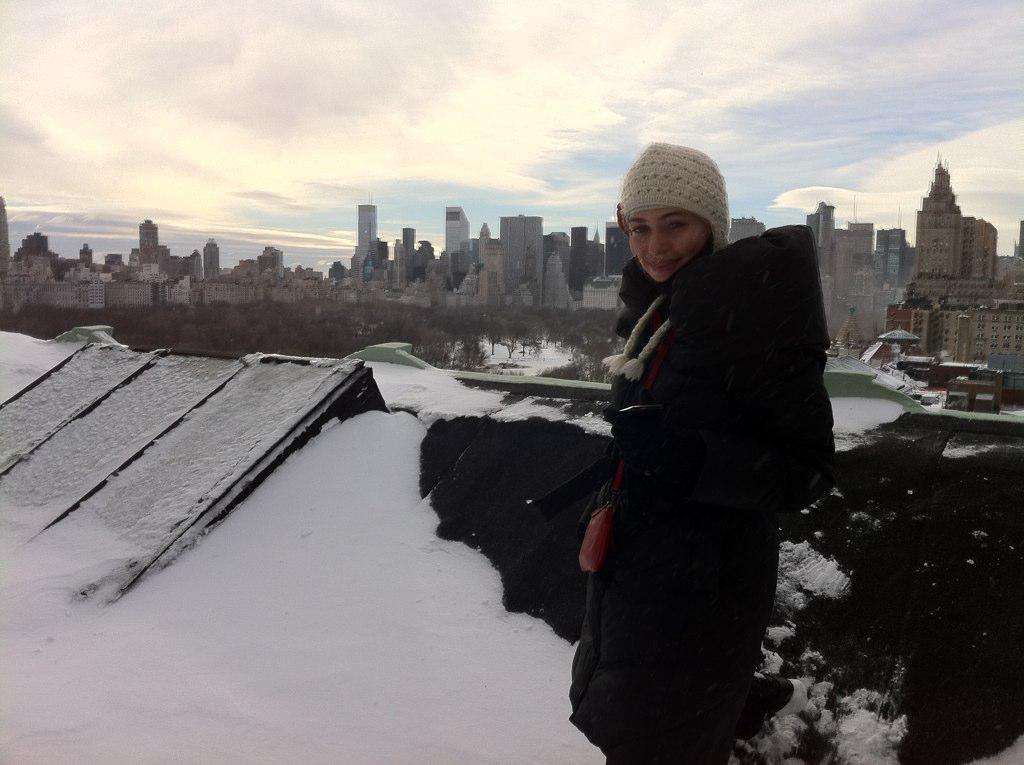What is the main subject of the image? There is a woman standing in the image. What is the condition of the ground in the image? There is snow on the ground in the image. What can be seen in the background of the image? There are buildings and trees in the background of the image. What is visible at the top of the image? The sky is visible at the top of the image. What type of shop can be seen in the image? There is no shop present in the image. How does the woman's wealth affect the image? The woman's wealth is not mentioned or depicted in the image, so it cannot be determined how it affects the image. 